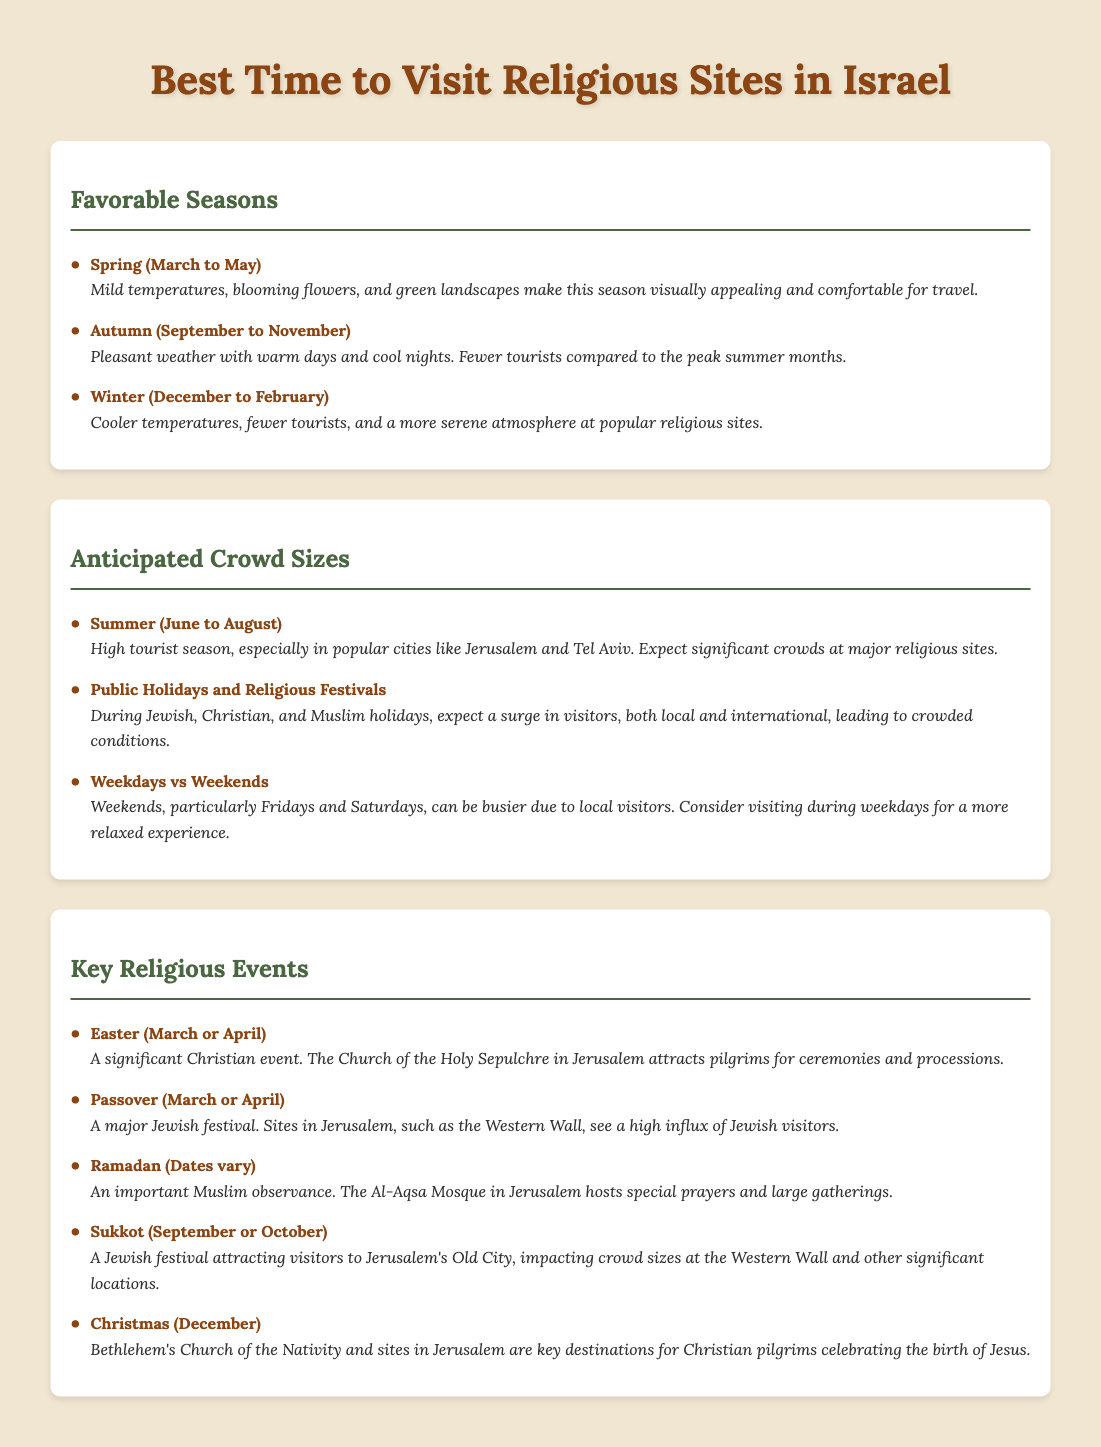what is the best season for traveling in Israel? Spring (March to May) is considered the best season for traveling in Israel due to mild temperatures and blooming landscapes.
Answer: Spring (March to May) which festival occurs in March or April? Easter and Passover are both significant festivals that occur in March or April, attracting many visitors.
Answer: Easter (March or April) and Passover (March or April) what is the expected crowd size during summer? Summer (June to August) is the high tourist season, meaning significant crowds at religious sites are expected.
Answer: Significant crowds when do weekends see a higher number of visitors? Weekends, particularly Fridays and Saturdays, can be busier due to local visitors.
Answer: Fridays and Saturdays which religious event involves special prayers at Al-Aqsa Mosque? Ramadan is the observance where special prayers and gatherings occur at the Al-Aqsa Mosque.
Answer: Ramadan what is the weather like during autumn? Autumn (September to November) features pleasant weather with warm days and cool nights, making it a favorable time to visit.
Answer: Pleasant weather name a religious site in Jerusalem associated with Christmas. Bethlehem's Church of the Nativity is a key destination for Christian pilgrims during Christmas.
Answer: Church of the Nativity how does winter affect tourist visitation? Winter (December to February) sees fewer tourists, allowing for a more serene atmosphere at religious sites.
Answer: Fewer tourists 